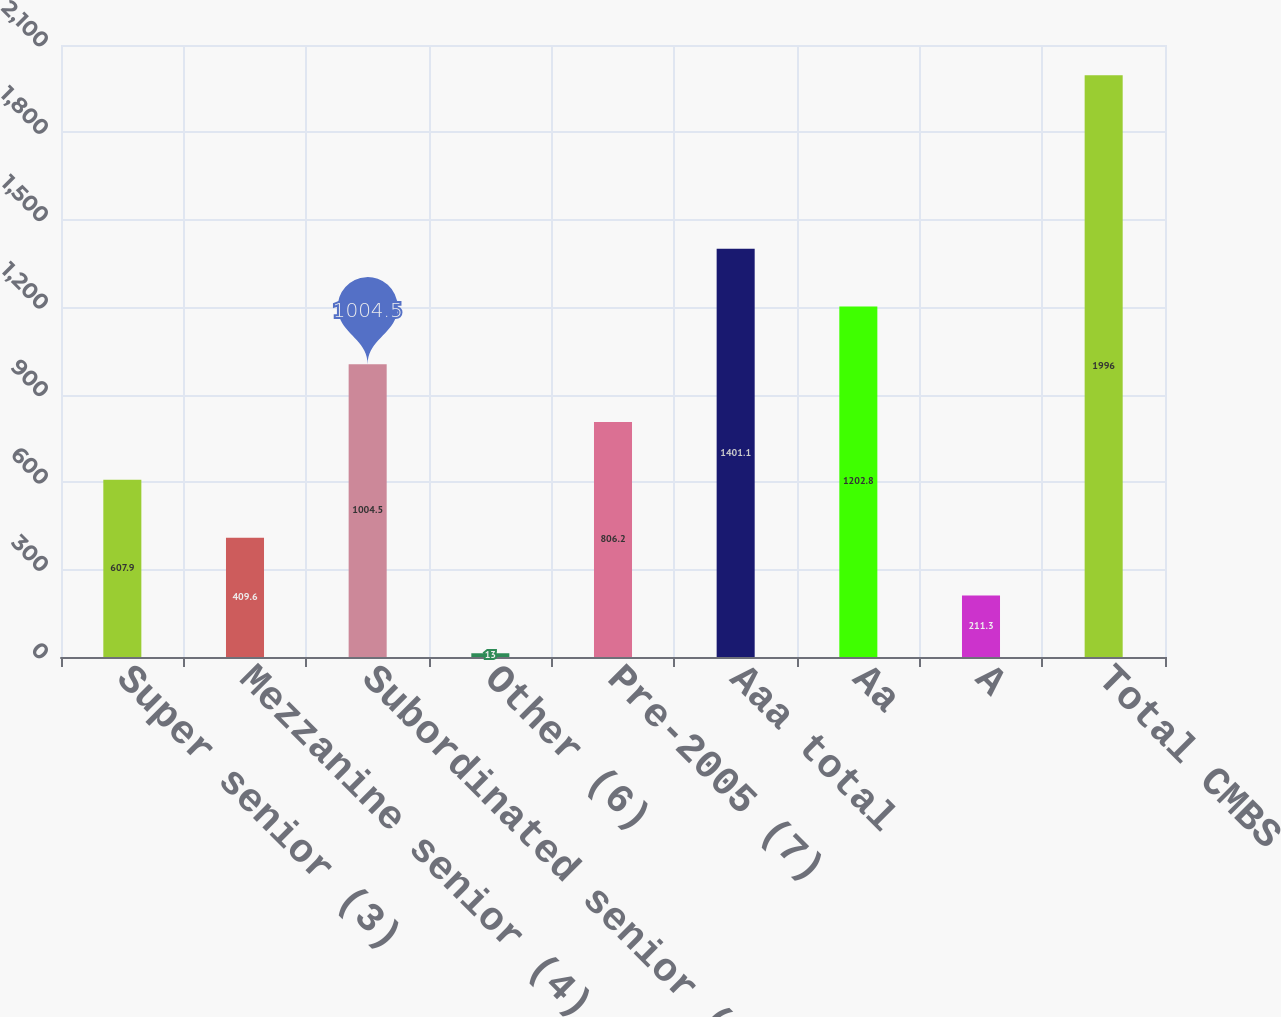Convert chart to OTSL. <chart><loc_0><loc_0><loc_500><loc_500><bar_chart><fcel>Super senior (3)<fcel>Mezzanine senior (4)<fcel>Subordinated senior (5)<fcel>Other (6)<fcel>Pre-2005 (7)<fcel>Aaa total<fcel>Aa<fcel>A<fcel>Total CMBS<nl><fcel>607.9<fcel>409.6<fcel>1004.5<fcel>13<fcel>806.2<fcel>1401.1<fcel>1202.8<fcel>211.3<fcel>1996<nl></chart> 